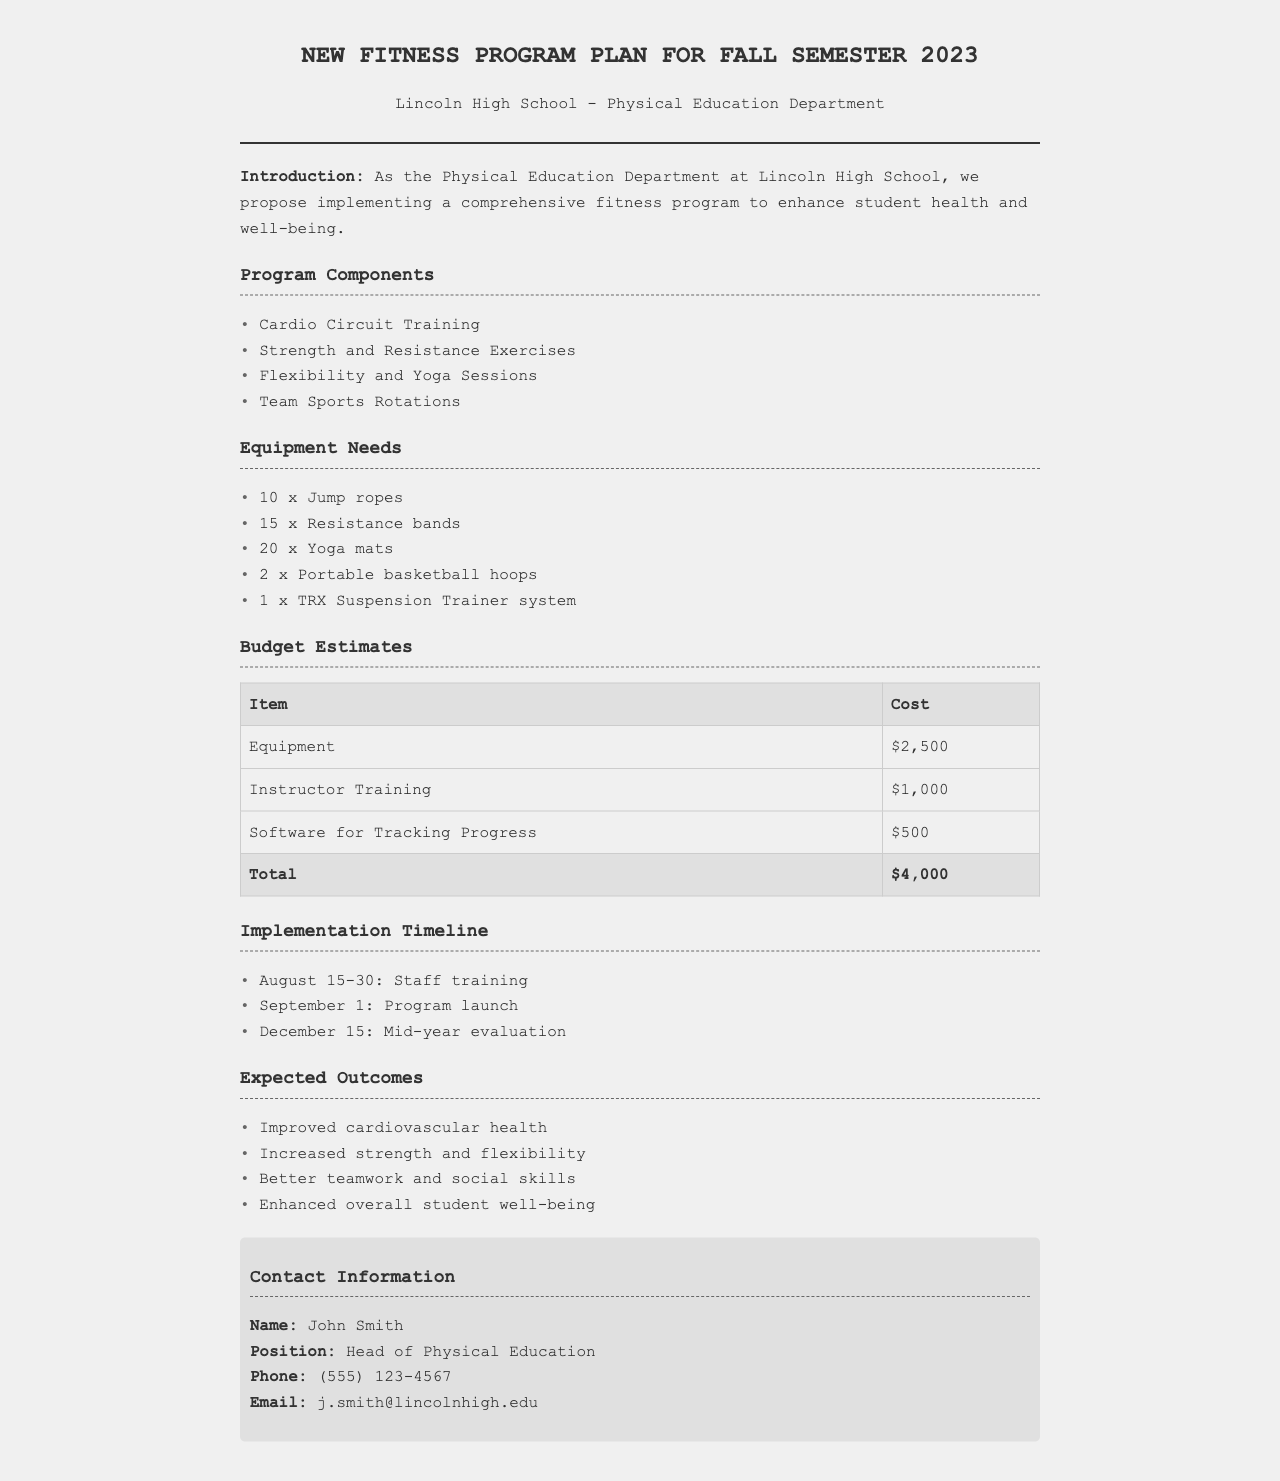What is the program launch date? The program launch date is specified in the implementation timeline section of the document, which states "September 1".
Answer: September 1 How many yoga mats are needed? The equipment needs section lists "20 x Yoga mats", specifying the quantity required for the program.
Answer: 20 What is the total budget estimate? The budget estimates section concludes with a total cost where it shows the sum of all costs as "$4,000".
Answer: $4,000 Who is the head of physical education? The contact information section reveals the head of physical education as "John Smith".
Answer: John Smith What is one expected outcome of the program? The expected outcomes section lists several results; one of them is "Improved cardiovascular health".
Answer: Improved cardiovascular health How much will instructor training cost? The budget estimates indicate that the cost for instructor training is "$1,000".
Answer: $1,000 What equipment will be used for strength training? Among the equipment needs, "Resistance bands" are typically used for strength and resistance exercises.
Answer: Resistance bands When will the mid-year evaluation occur? According to the implementation timeline, the mid-year evaluation is scheduled for "December 15".
Answer: December 15 